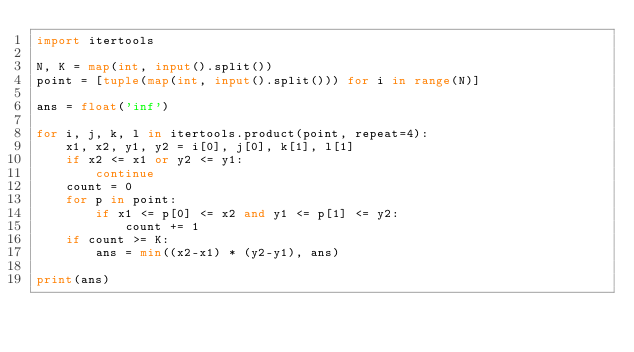Convert code to text. <code><loc_0><loc_0><loc_500><loc_500><_Python_>import itertools

N, K = map(int, input().split())
point = [tuple(map(int, input().split())) for i in range(N)]

ans = float('inf')

for i, j, k, l in itertools.product(point, repeat=4):
    x1, x2, y1, y2 = i[0], j[0], k[1], l[1]
    if x2 <= x1 or y2 <= y1:
        continue
    count = 0
    for p in point:
        if x1 <= p[0] <= x2 and y1 <= p[1] <= y2:
            count += 1
    if count >= K:
        ans = min((x2-x1) * (y2-y1), ans)

print(ans)</code> 